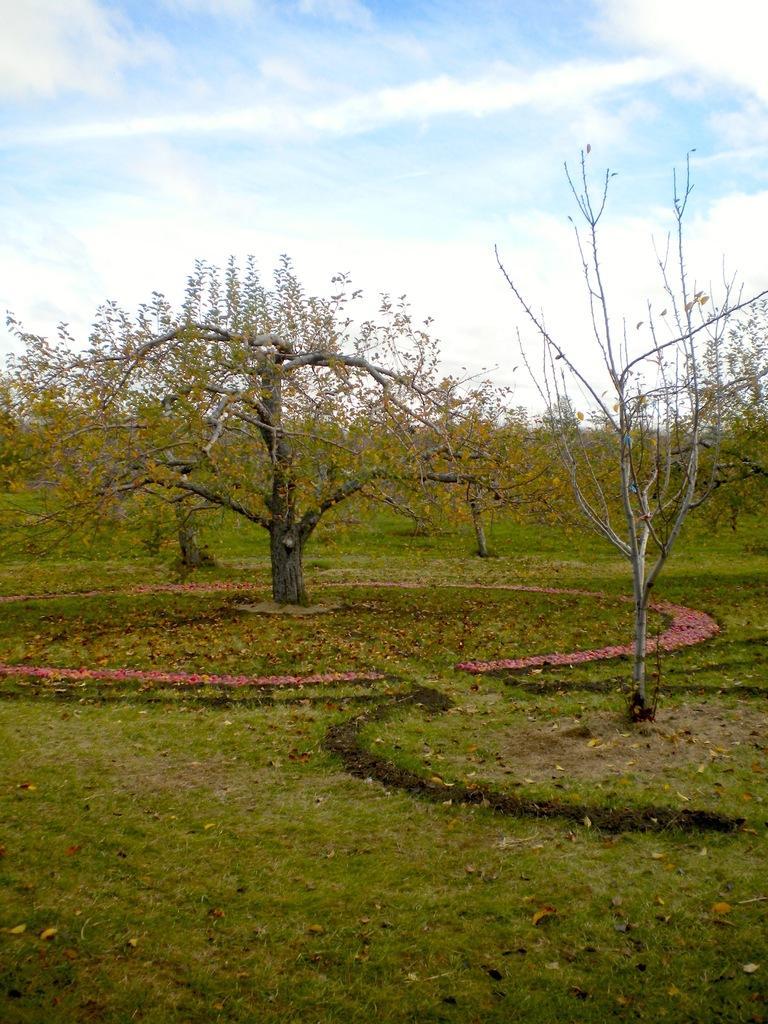Can you describe this image briefly? In this picture we can see grass, few trees and clouds. 